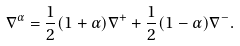<formula> <loc_0><loc_0><loc_500><loc_500>\nabla ^ { \alpha } = \frac { 1 } { 2 } ( 1 + \alpha ) \nabla ^ { + } + \frac { 1 } { 2 } ( 1 - \alpha ) \nabla ^ { - } .</formula> 